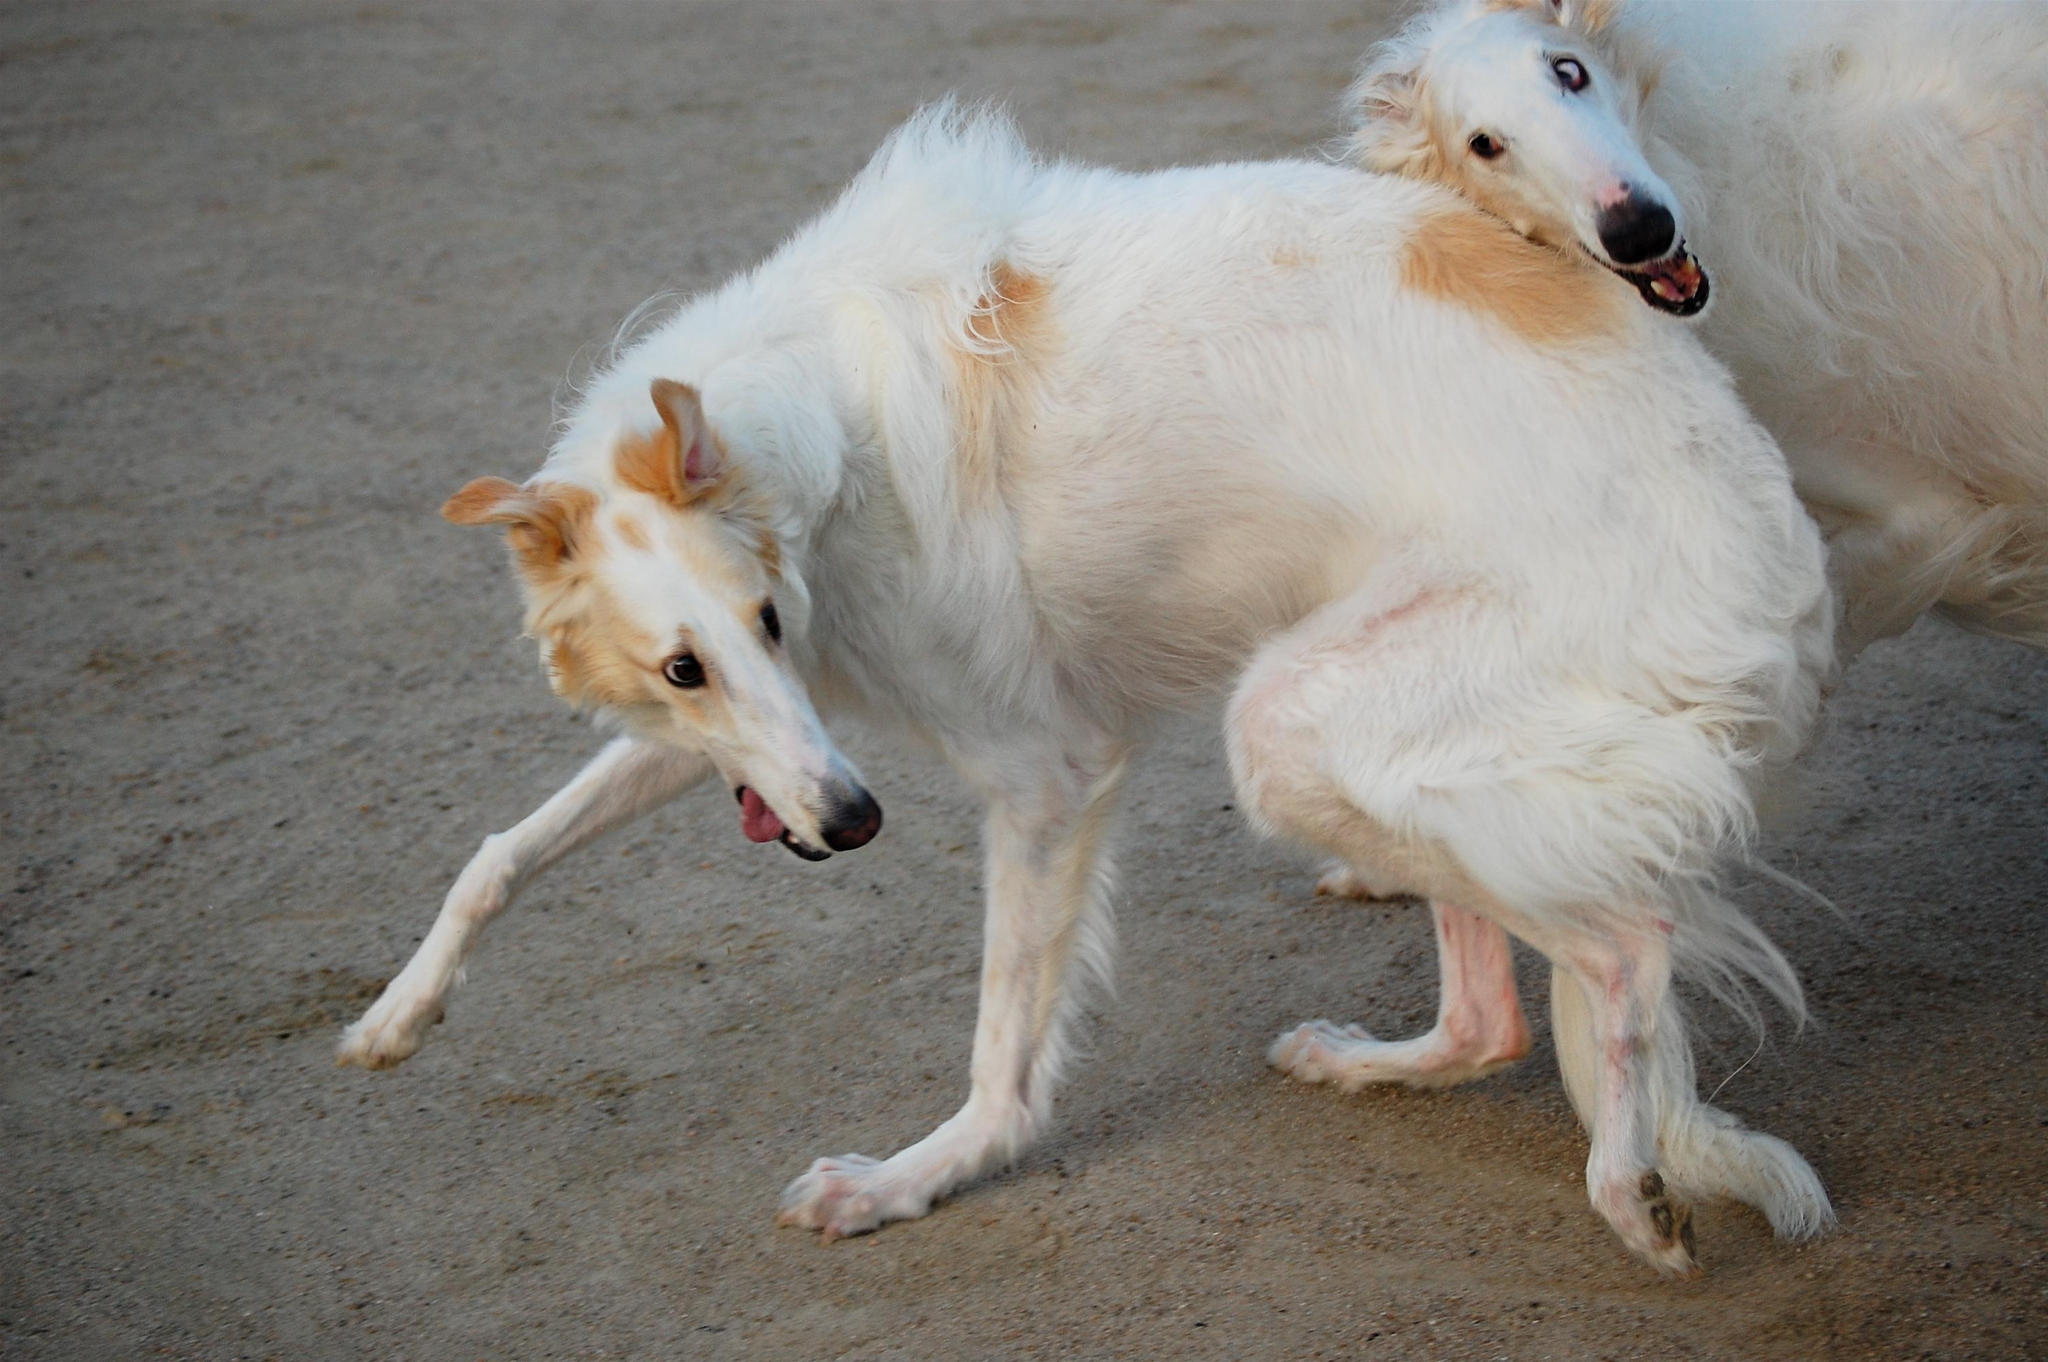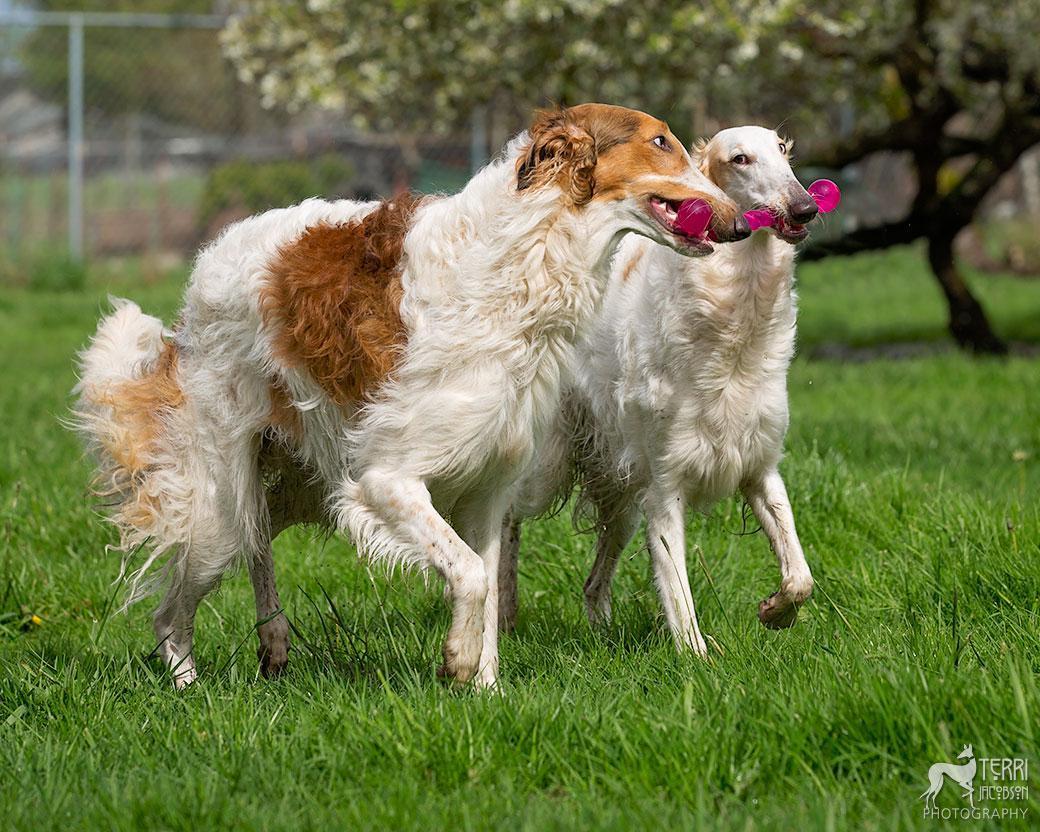The first image is the image on the left, the second image is the image on the right. Given the left and right images, does the statement "Two dogs are running together in a field of grass." hold true? Answer yes or no. Yes. 